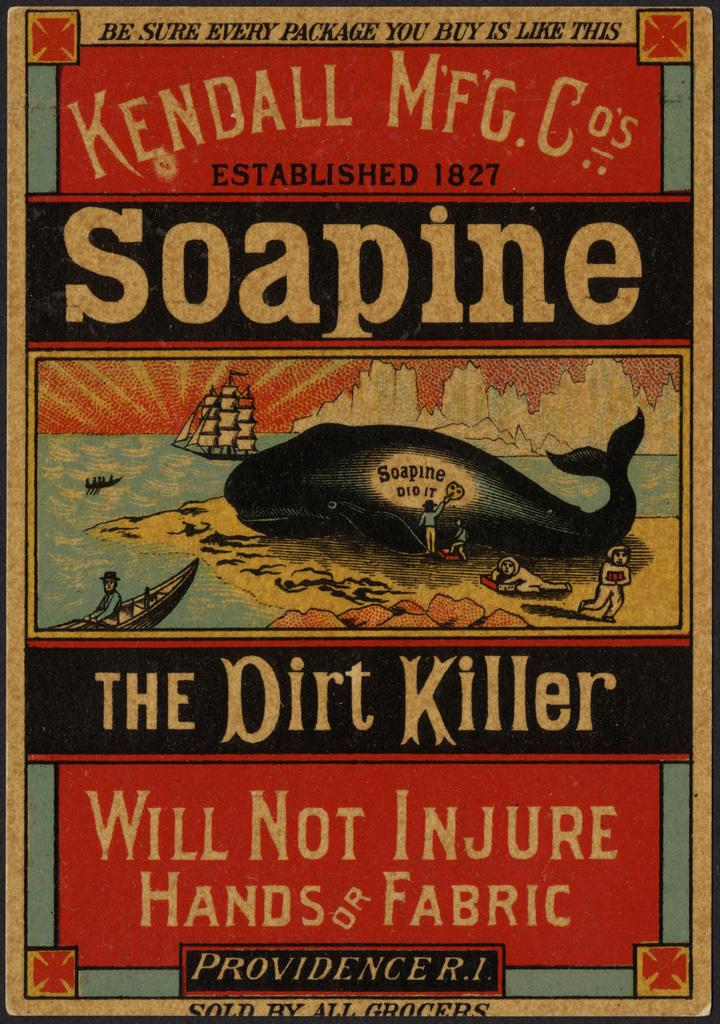Provide a one-sentence caption for the provided image. front cover of a book named the dirt killer. 